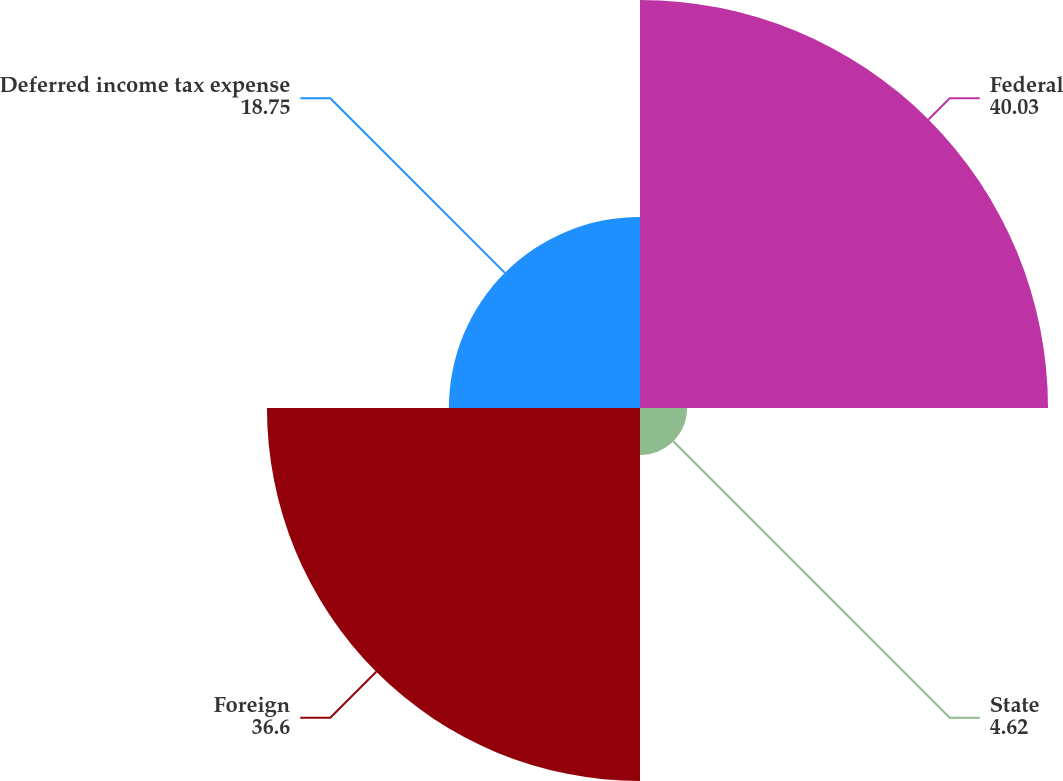Convert chart. <chart><loc_0><loc_0><loc_500><loc_500><pie_chart><fcel>Federal<fcel>State<fcel>Foreign<fcel>Deferred income tax expense<nl><fcel>40.03%<fcel>4.62%<fcel>36.6%<fcel>18.75%<nl></chart> 